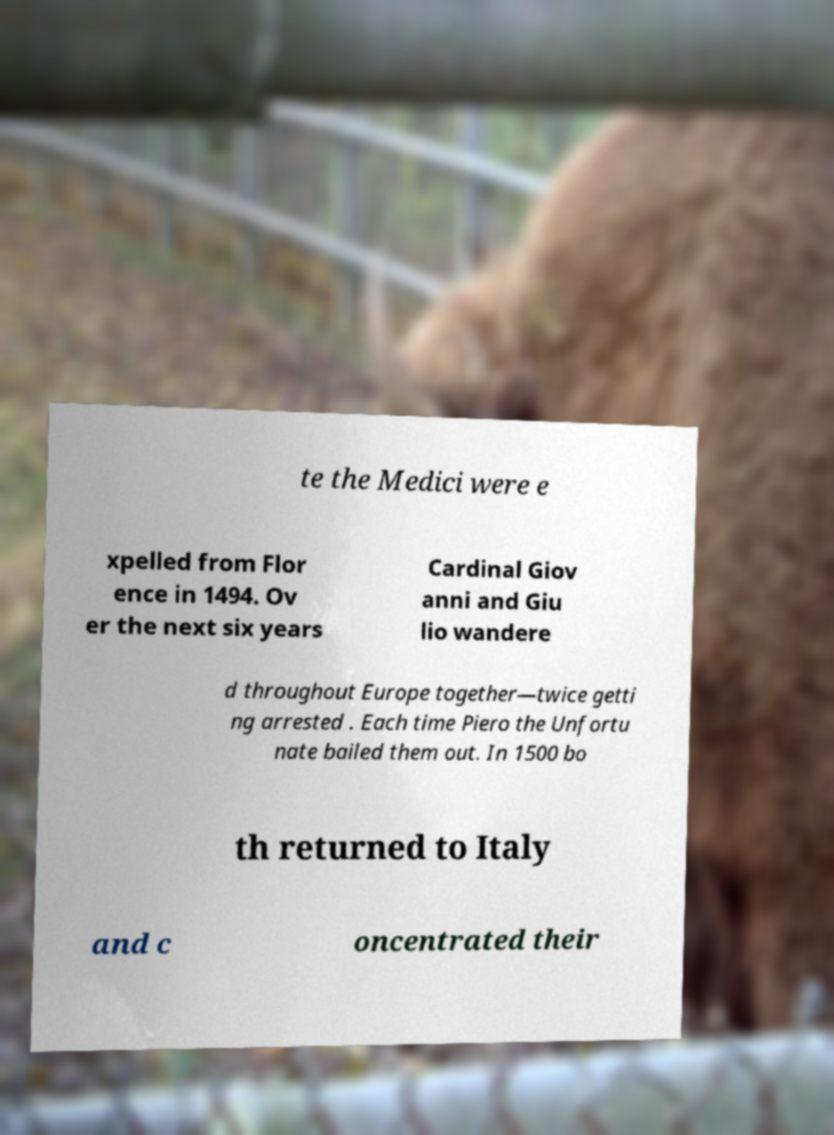Please identify and transcribe the text found in this image. te the Medici were e xpelled from Flor ence in 1494. Ov er the next six years Cardinal Giov anni and Giu lio wandere d throughout Europe together—twice getti ng arrested . Each time Piero the Unfortu nate bailed them out. In 1500 bo th returned to Italy and c oncentrated their 